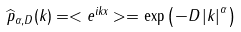<formula> <loc_0><loc_0><loc_500><loc_500>\widehat { p } _ { \alpha , D } ( k ) = < e ^ { i k x } > = \exp \left ( - D \left | k \right | ^ { \alpha } \right )</formula> 